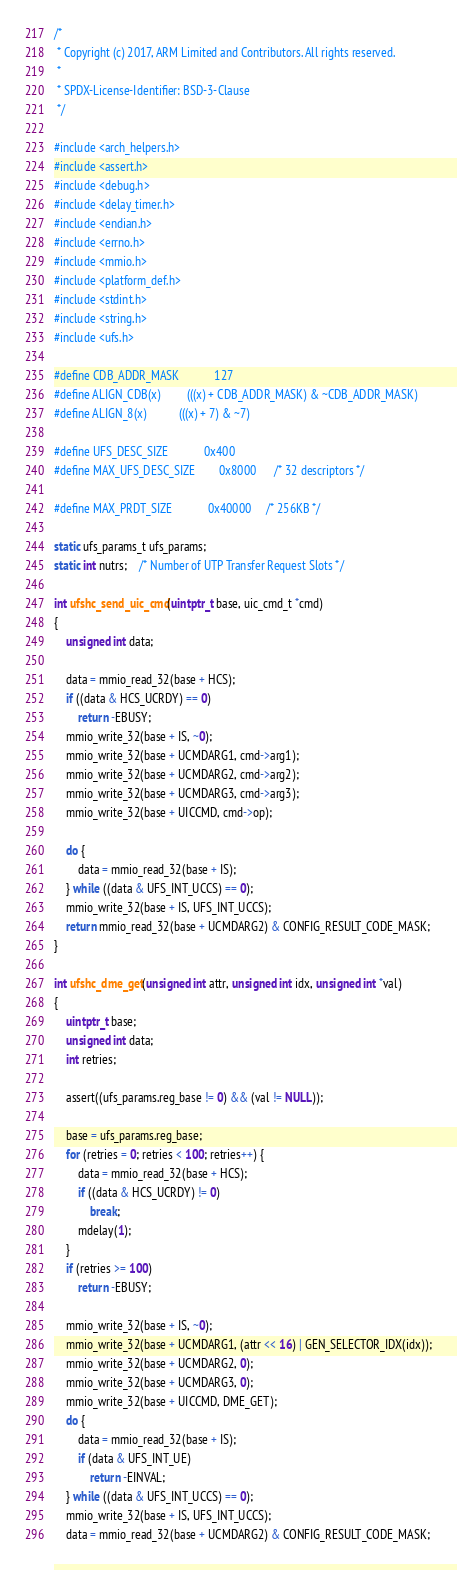Convert code to text. <code><loc_0><loc_0><loc_500><loc_500><_C_>/*
 * Copyright (c) 2017, ARM Limited and Contributors. All rights reserved.
 *
 * SPDX-License-Identifier: BSD-3-Clause
 */

#include <arch_helpers.h>
#include <assert.h>
#include <debug.h>
#include <delay_timer.h>
#include <endian.h>
#include <errno.h>
#include <mmio.h>
#include <platform_def.h>
#include <stdint.h>
#include <string.h>
#include <ufs.h>

#define CDB_ADDR_MASK			127
#define ALIGN_CDB(x)			(((x) + CDB_ADDR_MASK) & ~CDB_ADDR_MASK)
#define ALIGN_8(x)			(((x) + 7) & ~7)

#define UFS_DESC_SIZE			0x400
#define MAX_UFS_DESC_SIZE		0x8000		/* 32 descriptors */

#define MAX_PRDT_SIZE			0x40000		/* 256KB */

static ufs_params_t ufs_params;
static int nutrs;	/* Number of UTP Transfer Request Slots */

int ufshc_send_uic_cmd(uintptr_t base, uic_cmd_t *cmd)
{
	unsigned int data;

	data = mmio_read_32(base + HCS);
	if ((data & HCS_UCRDY) == 0)
		return -EBUSY;
	mmio_write_32(base + IS, ~0);
	mmio_write_32(base + UCMDARG1, cmd->arg1);
	mmio_write_32(base + UCMDARG2, cmd->arg2);
	mmio_write_32(base + UCMDARG3, cmd->arg3);
	mmio_write_32(base + UICCMD, cmd->op);

	do {
		data = mmio_read_32(base + IS);
	} while ((data & UFS_INT_UCCS) == 0);
	mmio_write_32(base + IS, UFS_INT_UCCS);
	return mmio_read_32(base + UCMDARG2) & CONFIG_RESULT_CODE_MASK;
}

int ufshc_dme_get(unsigned int attr, unsigned int idx, unsigned int *val)
{
	uintptr_t base;
	unsigned int data;
	int retries;

	assert((ufs_params.reg_base != 0) && (val != NULL));

	base = ufs_params.reg_base;
	for (retries = 0; retries < 100; retries++) {
		data = mmio_read_32(base + HCS);
		if ((data & HCS_UCRDY) != 0)
			break;
		mdelay(1);
	}
	if (retries >= 100)
		return -EBUSY;

	mmio_write_32(base + IS, ~0);
	mmio_write_32(base + UCMDARG1, (attr << 16) | GEN_SELECTOR_IDX(idx));
	mmio_write_32(base + UCMDARG2, 0);
	mmio_write_32(base + UCMDARG3, 0);
	mmio_write_32(base + UICCMD, DME_GET);
	do {
		data = mmio_read_32(base + IS);
		if (data & UFS_INT_UE)
			return -EINVAL;
	} while ((data & UFS_INT_UCCS) == 0);
	mmio_write_32(base + IS, UFS_INT_UCCS);
	data = mmio_read_32(base + UCMDARG2) & CONFIG_RESULT_CODE_MASK;</code> 